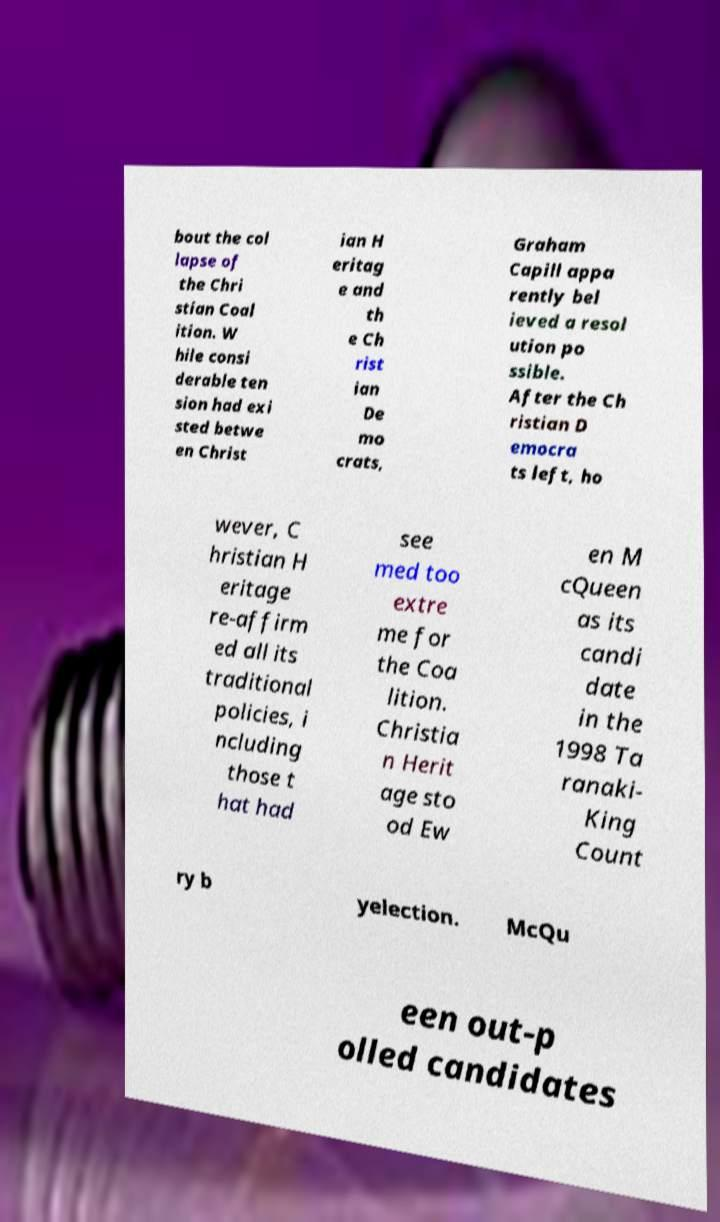What messages or text are displayed in this image? I need them in a readable, typed format. bout the col lapse of the Chri stian Coal ition. W hile consi derable ten sion had exi sted betwe en Christ ian H eritag e and th e Ch rist ian De mo crats, Graham Capill appa rently bel ieved a resol ution po ssible. After the Ch ristian D emocra ts left, ho wever, C hristian H eritage re-affirm ed all its traditional policies, i ncluding those t hat had see med too extre me for the Coa lition. Christia n Herit age sto od Ew en M cQueen as its candi date in the 1998 Ta ranaki- King Count ry b yelection. McQu een out-p olled candidates 